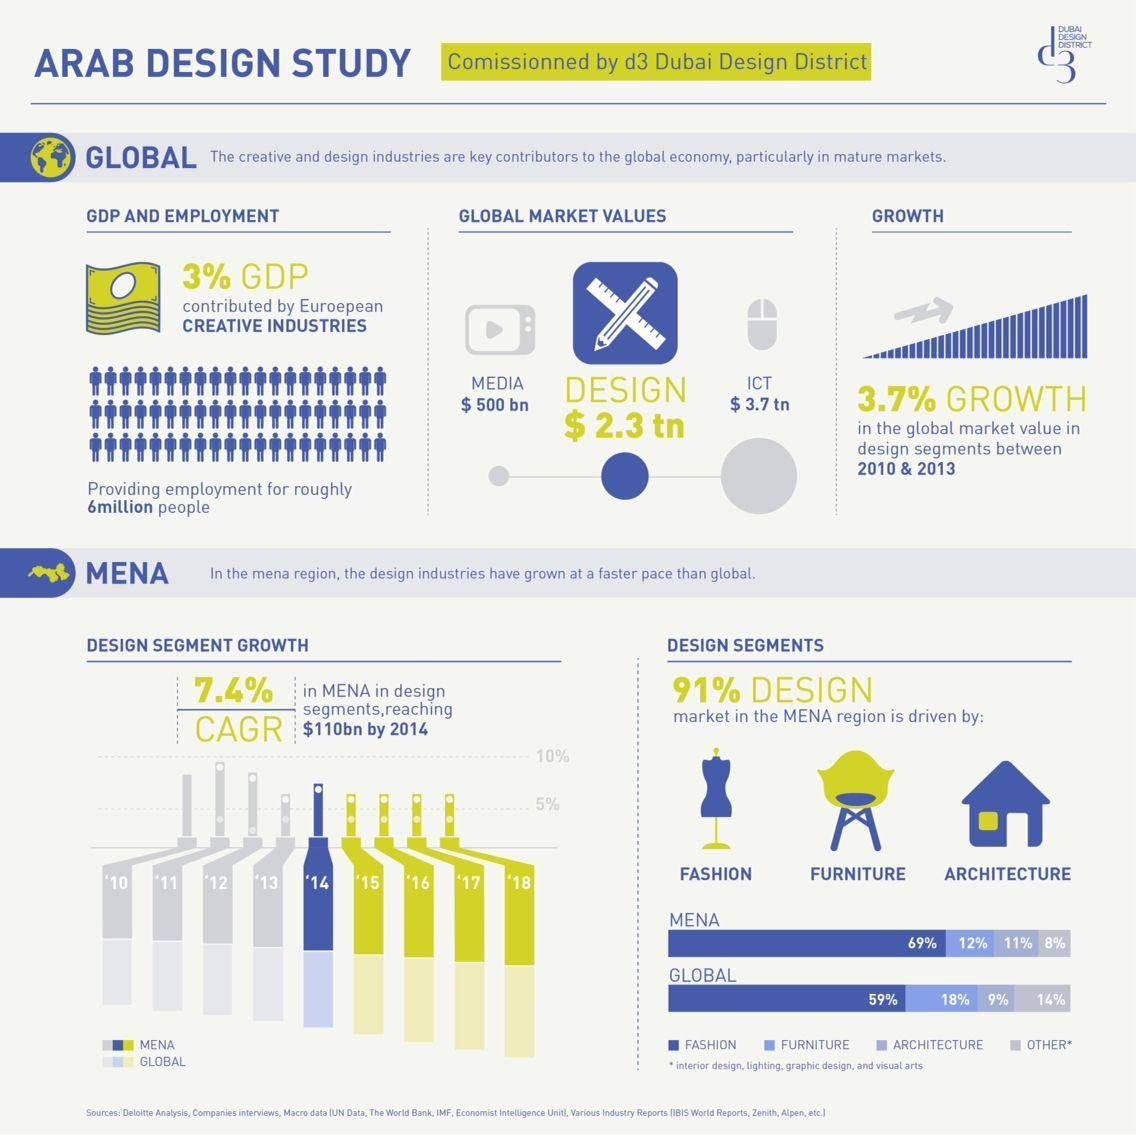What percentage of design market in the MENA region is driven by architecture?
Answer the question with a short phrase. 11% What is the global market value for media services? $ 500 bn What is the global market value for design services? $ 2.3 tn What percentage of design market in the MENA region is driven by Fashion? 69% What percentage of design market globally is driven by Fashion? 59% What percentage of design market globally  is driven by architecture? 9% 